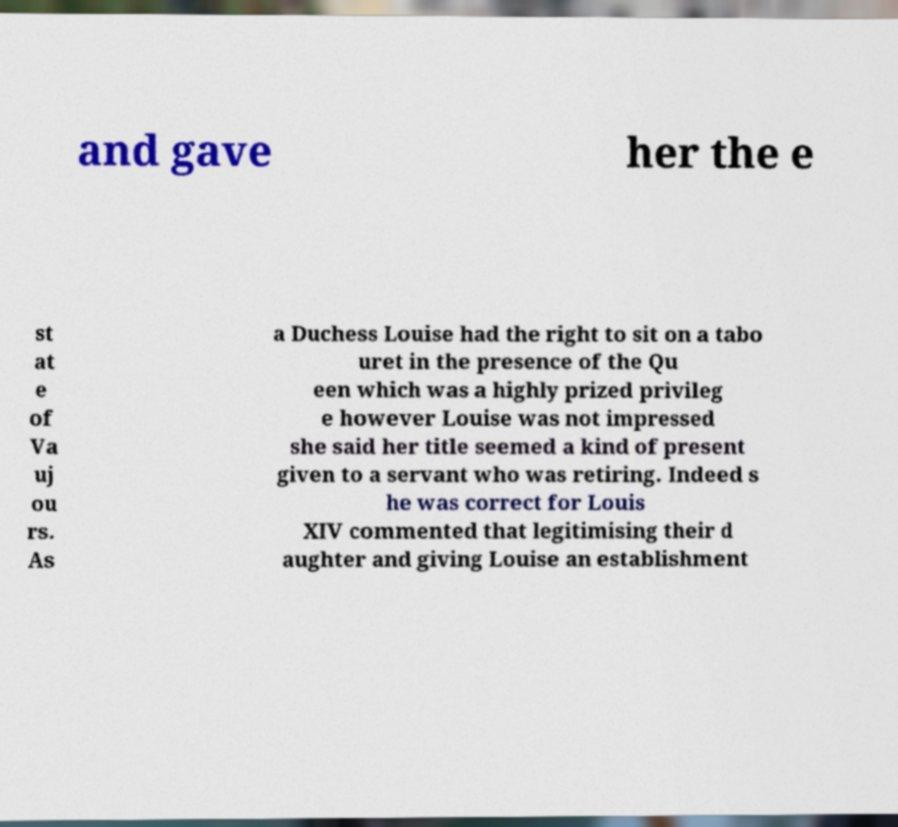What messages or text are displayed in this image? I need them in a readable, typed format. and gave her the e st at e of Va uj ou rs. As a Duchess Louise had the right to sit on a tabo uret in the presence of the Qu een which was a highly prized privileg e however Louise was not impressed she said her title seemed a kind of present given to a servant who was retiring. Indeed s he was correct for Louis XIV commented that legitimising their d aughter and giving Louise an establishment 